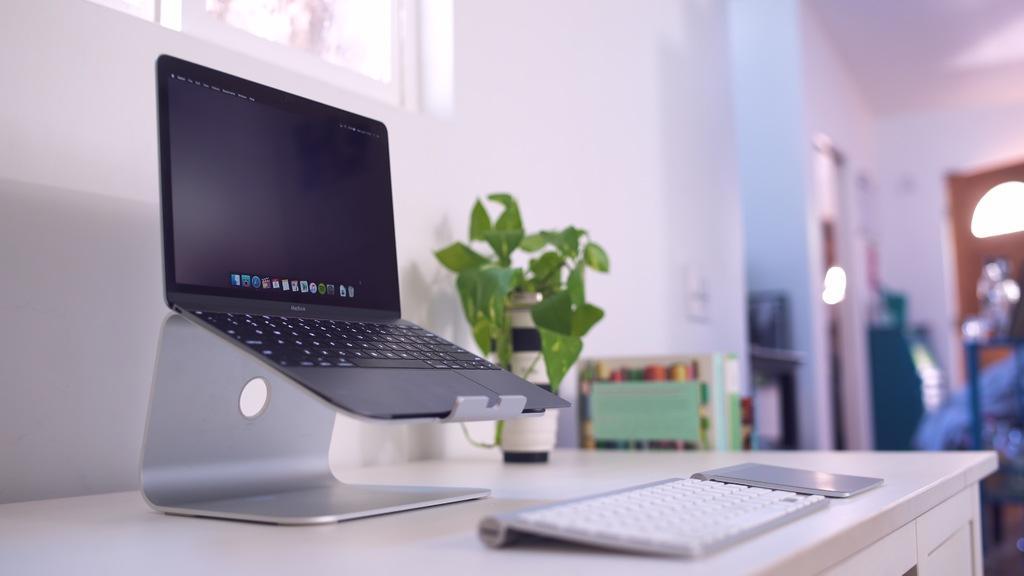Describe this image in one or two sentences. In this image there is a table, on that table there is a laptop, keyboard and a plant, in the background it is blurred. 